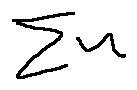<formula> <loc_0><loc_0><loc_500><loc_500>\sum u</formula> 